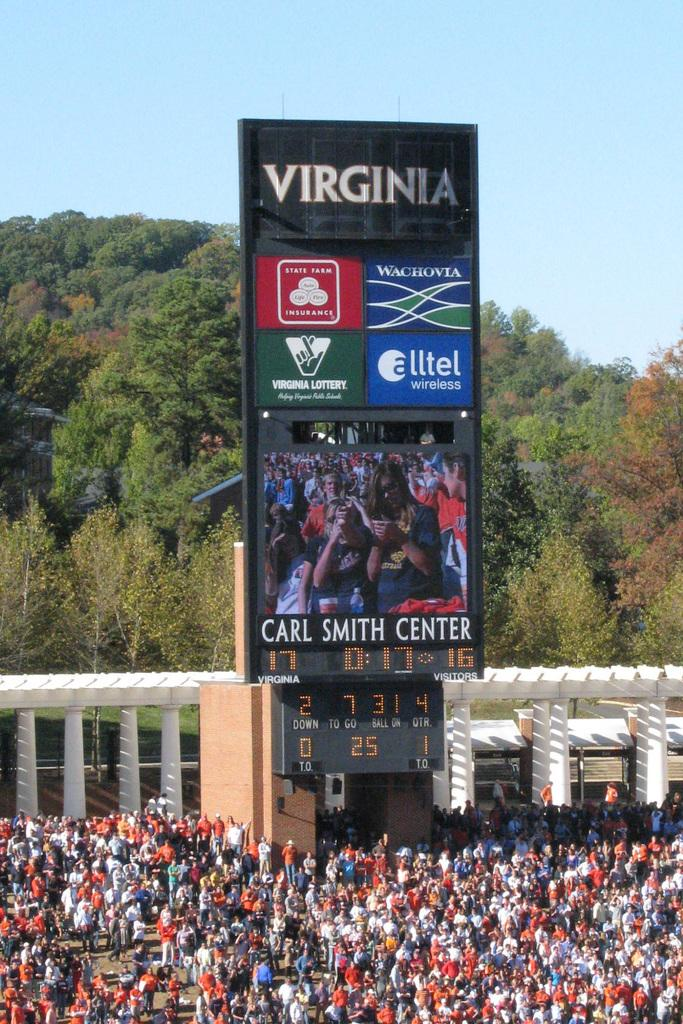<image>
Create a compact narrative representing the image presented. Large crowd outside the Carl Smith Center and trees in the background. 